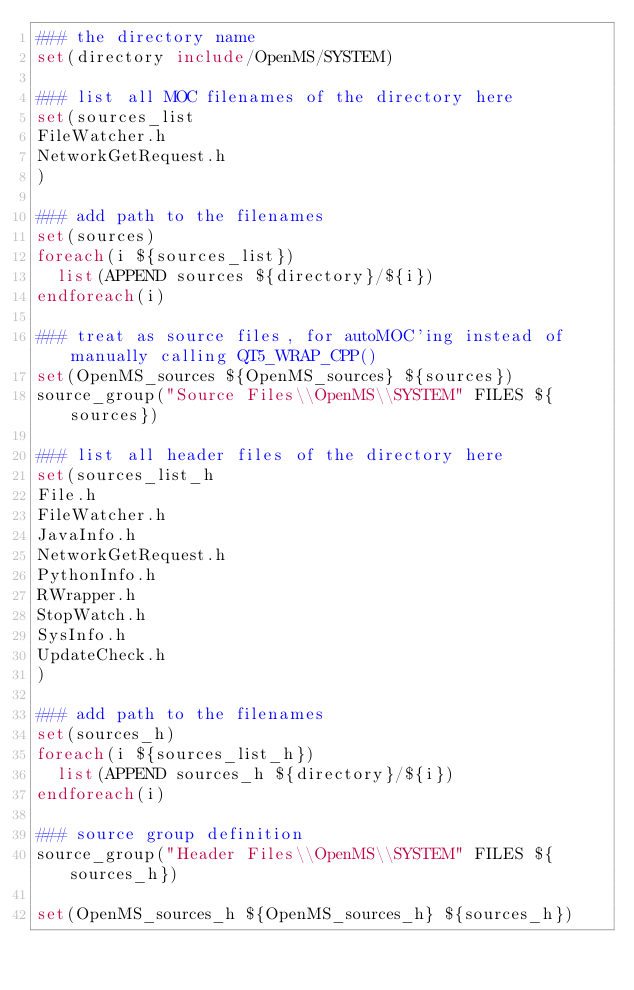<code> <loc_0><loc_0><loc_500><loc_500><_CMake_>### the directory name
set(directory include/OpenMS/SYSTEM)

### list all MOC filenames of the directory here
set(sources_list
FileWatcher.h
NetworkGetRequest.h
)

### add path to the filenames
set(sources)
foreach(i ${sources_list})
  list(APPEND sources ${directory}/${i})
endforeach(i)

### treat as source files, for autoMOC'ing instead of manually calling QT5_WRAP_CPP()
set(OpenMS_sources ${OpenMS_sources} ${sources})
source_group("Source Files\\OpenMS\\SYSTEM" FILES ${sources})

### list all header files of the directory here
set(sources_list_h
File.h
FileWatcher.h
JavaInfo.h
NetworkGetRequest.h
PythonInfo.h
RWrapper.h
StopWatch.h
SysInfo.h
UpdateCheck.h
)

### add path to the filenames
set(sources_h)
foreach(i ${sources_list_h})
	list(APPEND sources_h ${directory}/${i})
endforeach(i)

### source group definition
source_group("Header Files\\OpenMS\\SYSTEM" FILES ${sources_h})

set(OpenMS_sources_h ${OpenMS_sources_h} ${sources_h})

</code> 